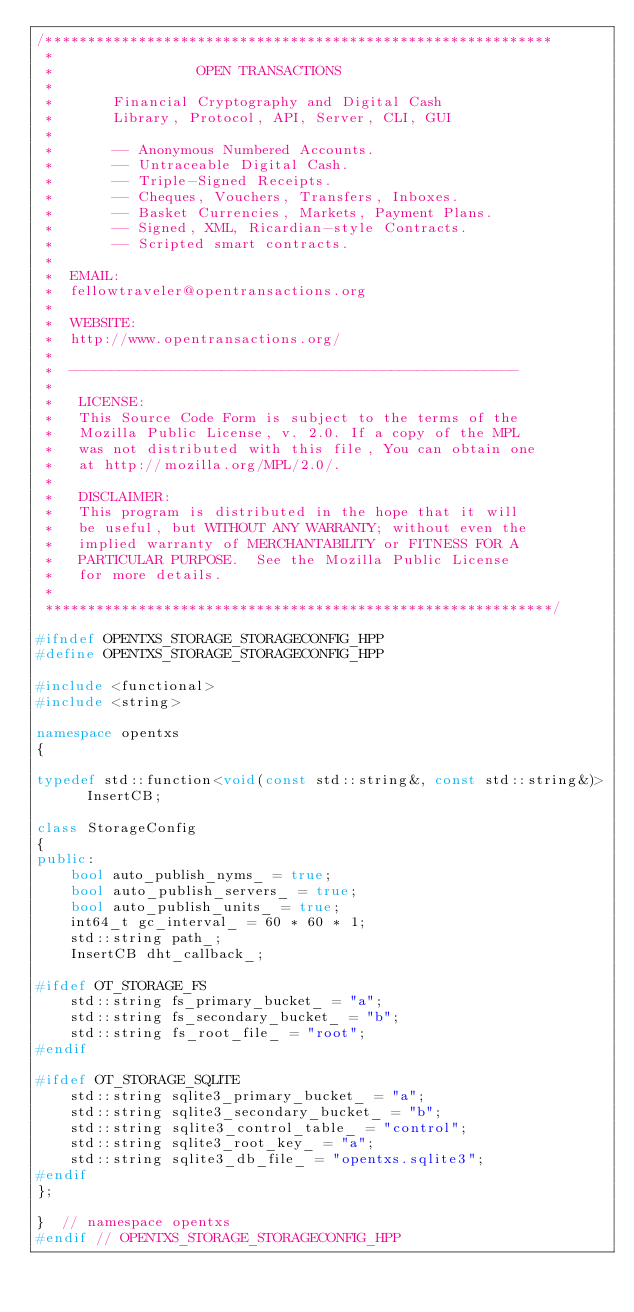<code> <loc_0><loc_0><loc_500><loc_500><_C++_>/************************************************************
 *
 *                 OPEN TRANSACTIONS
 *
 *       Financial Cryptography and Digital Cash
 *       Library, Protocol, API, Server, CLI, GUI
 *
 *       -- Anonymous Numbered Accounts.
 *       -- Untraceable Digital Cash.
 *       -- Triple-Signed Receipts.
 *       -- Cheques, Vouchers, Transfers, Inboxes.
 *       -- Basket Currencies, Markets, Payment Plans.
 *       -- Signed, XML, Ricardian-style Contracts.
 *       -- Scripted smart contracts.
 *
 *  EMAIL:
 *  fellowtraveler@opentransactions.org
 *
 *  WEBSITE:
 *  http://www.opentransactions.org/
 *
 *  -----------------------------------------------------
 *
 *   LICENSE:
 *   This Source Code Form is subject to the terms of the
 *   Mozilla Public License, v. 2.0. If a copy of the MPL
 *   was not distributed with this file, You can obtain one
 *   at http://mozilla.org/MPL/2.0/.
 *
 *   DISCLAIMER:
 *   This program is distributed in the hope that it will
 *   be useful, but WITHOUT ANY WARRANTY; without even the
 *   implied warranty of MERCHANTABILITY or FITNESS FOR A
 *   PARTICULAR PURPOSE.  See the Mozilla Public License
 *   for more details.
 *
 ************************************************************/

#ifndef OPENTXS_STORAGE_STORAGECONFIG_HPP
#define OPENTXS_STORAGE_STORAGECONFIG_HPP

#include <functional>
#include <string>

namespace opentxs
{

typedef std::function<void(const std::string&, const std::string&)>  InsertCB;

class StorageConfig
{
public:
    bool auto_publish_nyms_ = true;
    bool auto_publish_servers_ = true;
    bool auto_publish_units_ = true;
    int64_t gc_interval_ = 60 * 60 * 1;
    std::string path_;
    InsertCB dht_callback_;

#ifdef OT_STORAGE_FS
    std::string fs_primary_bucket_ = "a";
    std::string fs_secondary_bucket_ = "b";
    std::string fs_root_file_ = "root";
#endif

#ifdef OT_STORAGE_SQLITE
    std::string sqlite3_primary_bucket_ = "a";
    std::string sqlite3_secondary_bucket_ = "b";
    std::string sqlite3_control_table_ = "control";
    std::string sqlite3_root_key_ = "a";
    std::string sqlite3_db_file_ = "opentxs.sqlite3";
#endif
};

}  // namespace opentxs
#endif // OPENTXS_STORAGE_STORAGECONFIG_HPP
</code> 